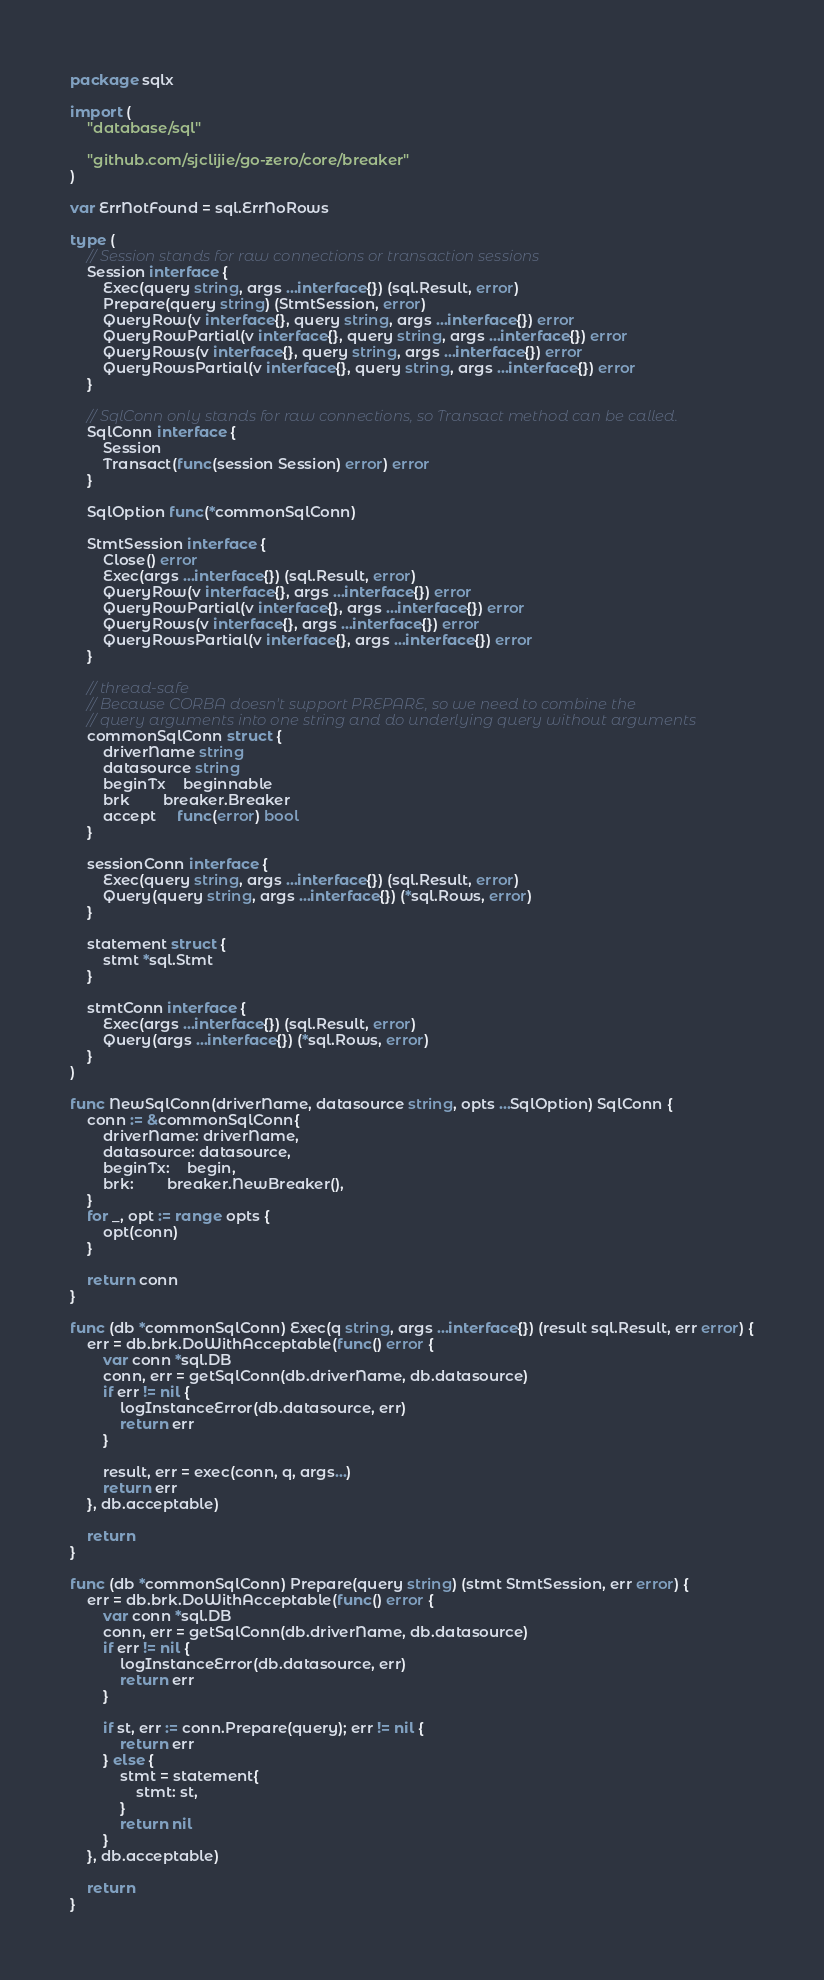Convert code to text. <code><loc_0><loc_0><loc_500><loc_500><_Go_>package sqlx

import (
	"database/sql"

	"github.com/sjclijie/go-zero/core/breaker"
)

var ErrNotFound = sql.ErrNoRows

type (
	// Session stands for raw connections or transaction sessions
	Session interface {
		Exec(query string, args ...interface{}) (sql.Result, error)
		Prepare(query string) (StmtSession, error)
		QueryRow(v interface{}, query string, args ...interface{}) error
		QueryRowPartial(v interface{}, query string, args ...interface{}) error
		QueryRows(v interface{}, query string, args ...interface{}) error
		QueryRowsPartial(v interface{}, query string, args ...interface{}) error
	}

	// SqlConn only stands for raw connections, so Transact method can be called.
	SqlConn interface {
		Session
		Transact(func(session Session) error) error
	}

	SqlOption func(*commonSqlConn)

	StmtSession interface {
		Close() error
		Exec(args ...interface{}) (sql.Result, error)
		QueryRow(v interface{}, args ...interface{}) error
		QueryRowPartial(v interface{}, args ...interface{}) error
		QueryRows(v interface{}, args ...interface{}) error
		QueryRowsPartial(v interface{}, args ...interface{}) error
	}

	// thread-safe
	// Because CORBA doesn't support PREPARE, so we need to combine the
	// query arguments into one string and do underlying query without arguments
	commonSqlConn struct {
		driverName string
		datasource string
		beginTx    beginnable
		brk        breaker.Breaker
		accept     func(error) bool
	}

	sessionConn interface {
		Exec(query string, args ...interface{}) (sql.Result, error)
		Query(query string, args ...interface{}) (*sql.Rows, error)
	}

	statement struct {
		stmt *sql.Stmt
	}

	stmtConn interface {
		Exec(args ...interface{}) (sql.Result, error)
		Query(args ...interface{}) (*sql.Rows, error)
	}
)

func NewSqlConn(driverName, datasource string, opts ...SqlOption) SqlConn {
	conn := &commonSqlConn{
		driverName: driverName,
		datasource: datasource,
		beginTx:    begin,
		brk:        breaker.NewBreaker(),
	}
	for _, opt := range opts {
		opt(conn)
	}

	return conn
}

func (db *commonSqlConn) Exec(q string, args ...interface{}) (result sql.Result, err error) {
	err = db.brk.DoWithAcceptable(func() error {
		var conn *sql.DB
		conn, err = getSqlConn(db.driverName, db.datasource)
		if err != nil {
			logInstanceError(db.datasource, err)
			return err
		}

		result, err = exec(conn, q, args...)
		return err
	}, db.acceptable)

	return
}

func (db *commonSqlConn) Prepare(query string) (stmt StmtSession, err error) {
	err = db.brk.DoWithAcceptable(func() error {
		var conn *sql.DB
		conn, err = getSqlConn(db.driverName, db.datasource)
		if err != nil {
			logInstanceError(db.datasource, err)
			return err
		}

		if st, err := conn.Prepare(query); err != nil {
			return err
		} else {
			stmt = statement{
				stmt: st,
			}
			return nil
		}
	}, db.acceptable)

	return
}
</code> 